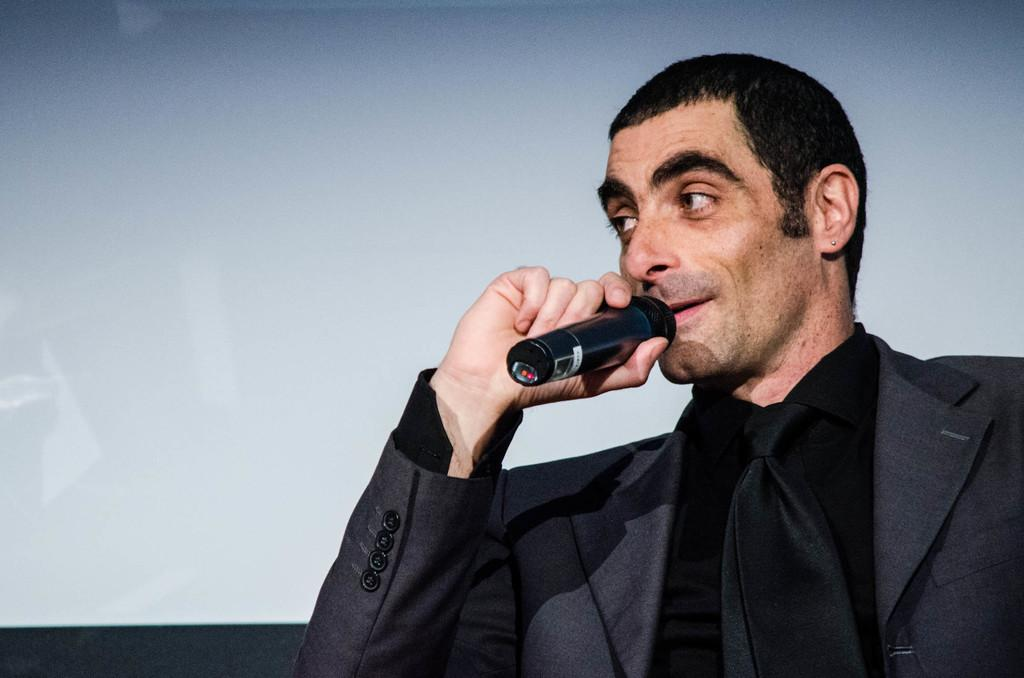Who or what is the main subject in the image? There is a person in the image. What is the person wearing? The person is wearing a blazer. What object is the person holding? The person is holding a microphone (mic). What type of cloud can be seen in the image? There is no cloud present in the image; it features a person wearing a blazer and holding a microphone. How is the pear being used in the image? There is no pear present in the image. 